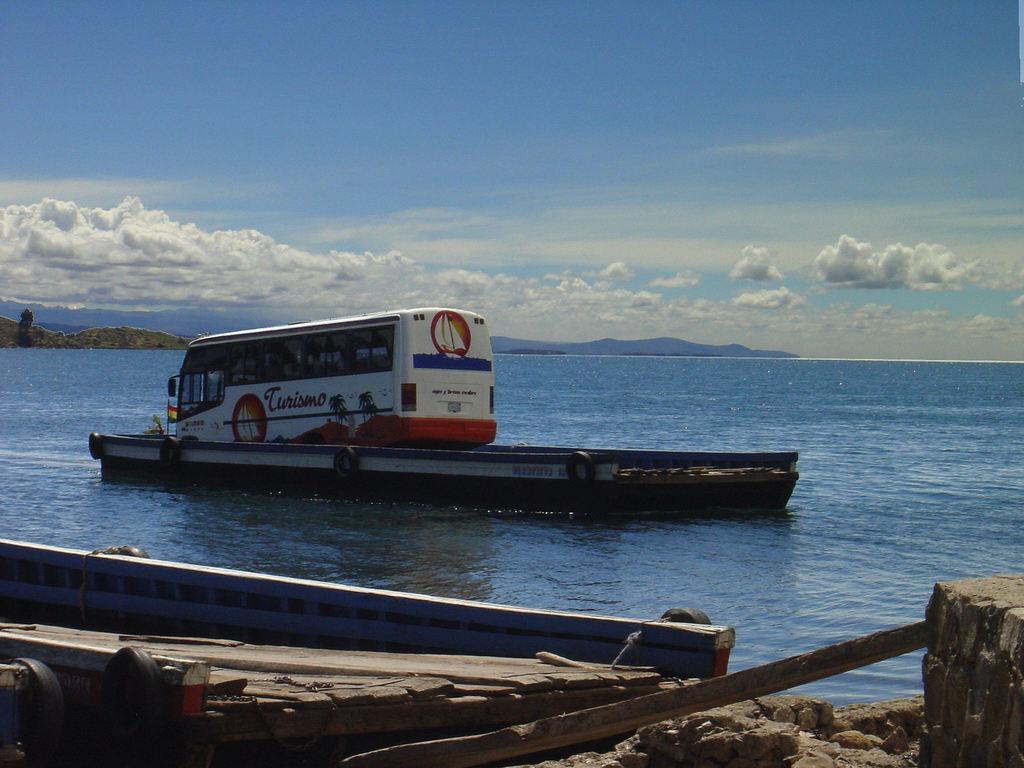In one or two sentences, can you explain what this image depicts? In this image, there is bus on the boat which is floating on the water. There is an another boat at the bottom of the image. In the background of the image, there is a sky. 